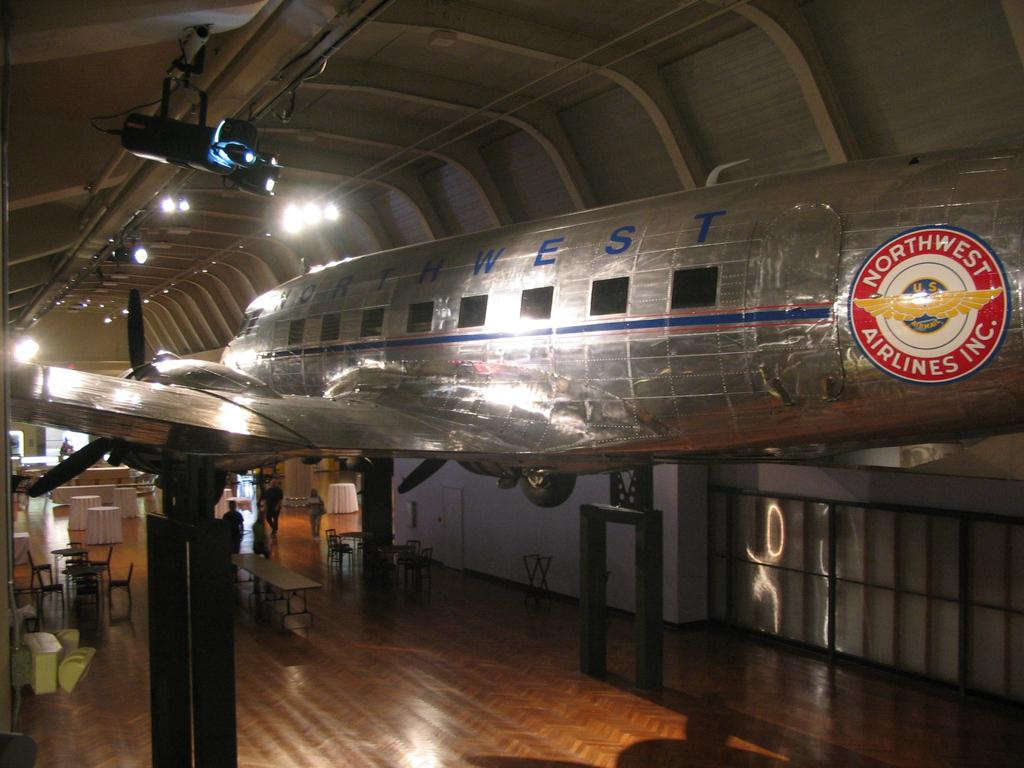<image>
Describe the image concisely. A silver airplane from Northwest Airlines is on display inside a building. 